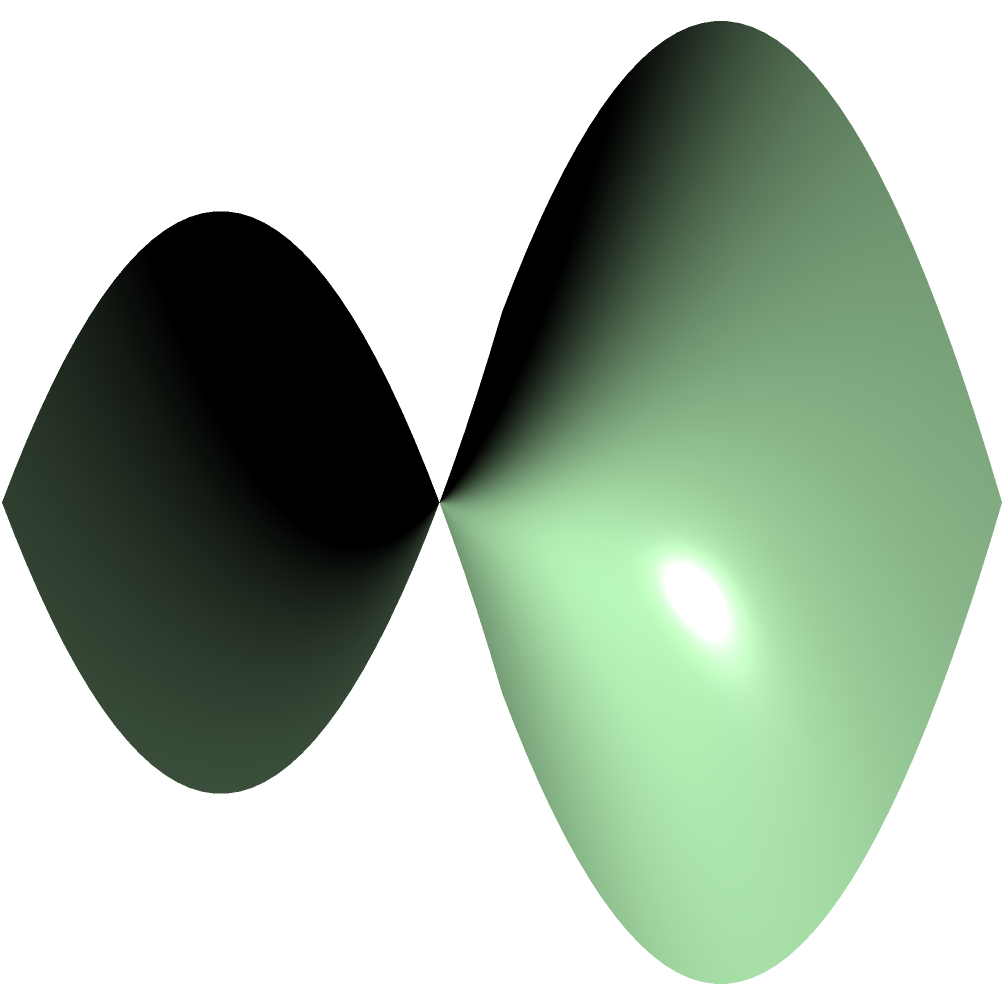Yo, check it! On this saddle-shaped surface, we've got a curved path that's the shortest distance between two points. In the world of Non-Euclidean Geometry, what do we call this type of path? Drop the knowledge! Alright, let's break it down like a fresh beat:

1. The surface we're looking at is called a saddle surface, defined by the equation $z = x^2 - y^2$.

2. In Euclidean geometry (flat space), the shortest path between two points is a straight line. But on curved surfaces like this, it's a different story.

3. The red curve on the surface represents the shortest path between two points on this saddle shape. It's not a straight line, but it follows the curvature of the surface.

4. In Non-Euclidean Geometry, specifically on curved surfaces, we call the curve that gives the shortest distance between two points a "geodesic".

5. Geodesics have some key properties:
   - They minimize the distance between two points on the surface.
   - They are the "straightest" possible curves on the surface.
   - If you were walking on this surface, following a geodesic would feel like walking in a straight line to you.

6. On a flat plane, geodesics are straight lines. But on curved surfaces like this saddle, they can be complex curves.

7. In the context of our rap game, you could think of a geodesic as the most efficient way to flow through a beat - the path that connects your bars most smoothly and directly.

So, when we're talking about the shortest path on a curved surface in Non-Euclidean Geometry, we're dropping the term "geodesic".
Answer: Geodesic 